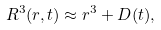Convert formula to latex. <formula><loc_0><loc_0><loc_500><loc_500>R ^ { 3 } ( r , t ) \approx r ^ { 3 } + D ( t ) ,</formula> 